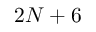<formula> <loc_0><loc_0><loc_500><loc_500>2 N + 6</formula> 